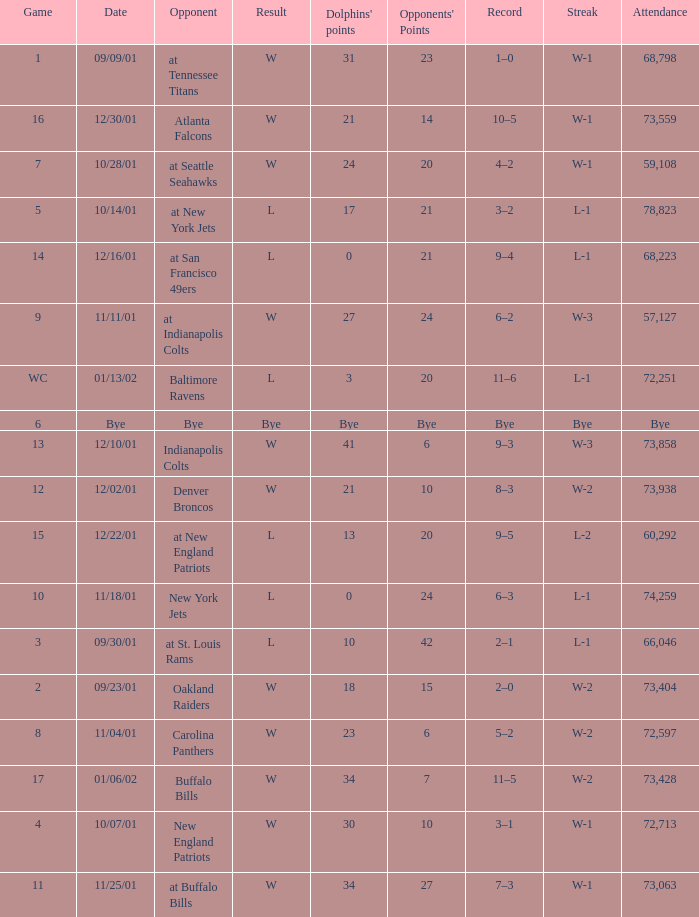Could you parse the entire table? {'header': ['Game', 'Date', 'Opponent', 'Result', "Dolphins' points", "Opponents' Points", 'Record', 'Streak', 'Attendance'], 'rows': [['1', '09/09/01', 'at Tennessee Titans', 'W', '31', '23', '1–0', 'W-1', '68,798'], ['16', '12/30/01', 'Atlanta Falcons', 'W', '21', '14', '10–5', 'W-1', '73,559'], ['7', '10/28/01', 'at Seattle Seahawks', 'W', '24', '20', '4–2', 'W-1', '59,108'], ['5', '10/14/01', 'at New York Jets', 'L', '17', '21', '3–2', 'L-1', '78,823'], ['14', '12/16/01', 'at San Francisco 49ers', 'L', '0', '21', '9–4', 'L-1', '68,223'], ['9', '11/11/01', 'at Indianapolis Colts', 'W', '27', '24', '6–2', 'W-3', '57,127'], ['WC', '01/13/02', 'Baltimore Ravens', 'L', '3', '20', '11–6', 'L-1', '72,251'], ['6', 'Bye', 'Bye', 'Bye', 'Bye', 'Bye', 'Bye', 'Bye', 'Bye'], ['13', '12/10/01', 'Indianapolis Colts', 'W', '41', '6', '9–3', 'W-3', '73,858'], ['12', '12/02/01', 'Denver Broncos', 'W', '21', '10', '8–3', 'W-2', '73,938'], ['15', '12/22/01', 'at New England Patriots', 'L', '13', '20', '9–5', 'L-2', '60,292'], ['10', '11/18/01', 'New York Jets', 'L', '0', '24', '6–3', 'L-1', '74,259'], ['3', '09/30/01', 'at St. Louis Rams', 'L', '10', '42', '2–1', 'L-1', '66,046'], ['2', '09/23/01', 'Oakland Raiders', 'W', '18', '15', '2–0', 'W-2', '73,404'], ['8', '11/04/01', 'Carolina Panthers', 'W', '23', '6', '5–2', 'W-2', '72,597'], ['17', '01/06/02', 'Buffalo Bills', 'W', '34', '7', '11–5', 'W-2', '73,428'], ['4', '10/07/01', 'New England Patriots', 'W', '30', '10', '3–1', 'W-1', '72,713'], ['11', '11/25/01', 'at Buffalo Bills', 'W', '34', '27', '7–3', 'W-1', '73,063']]} What is the streak for game 16 when the Dolphins had 21 points? W-1. 